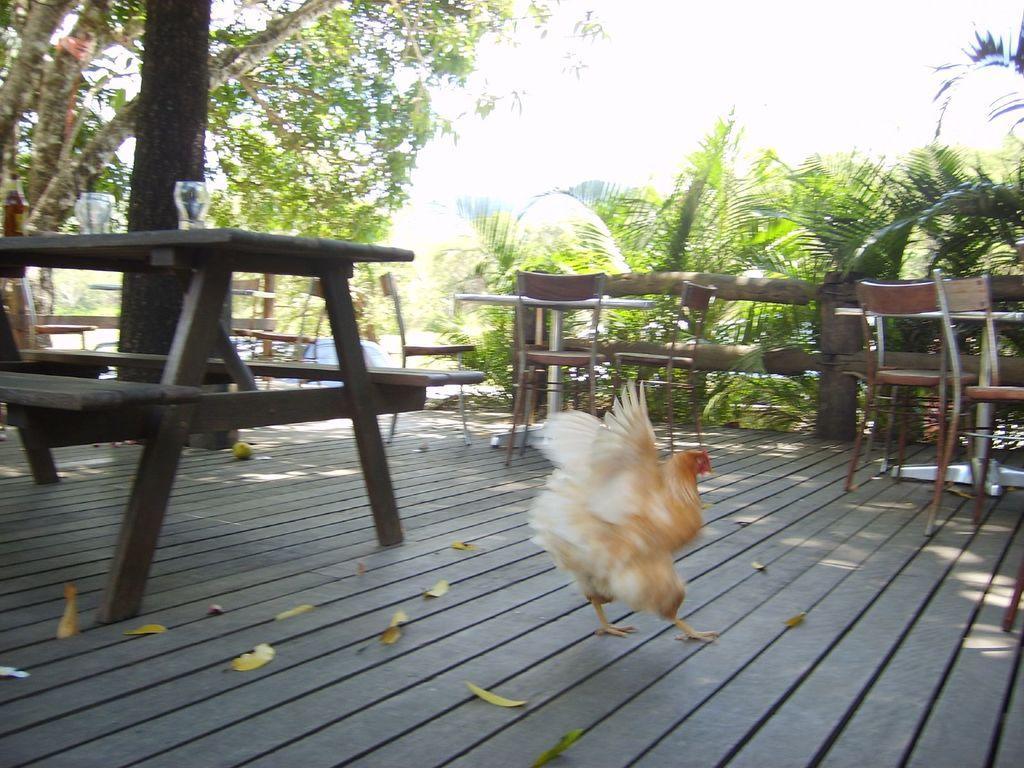How would you summarize this image in a sentence or two? Here we can see wooden floor and hen. There are so many benches and chairs. At the right side, we can see so many plants. Left side, there is a tree and trunck here. On top of table, we can see glasses. And background, we can see sky. 